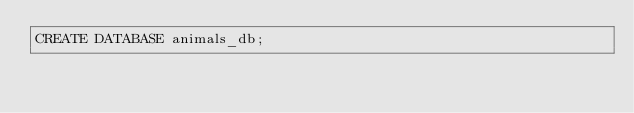<code> <loc_0><loc_0><loc_500><loc_500><_SQL_>CREATE DATABASE animals_db;</code> 